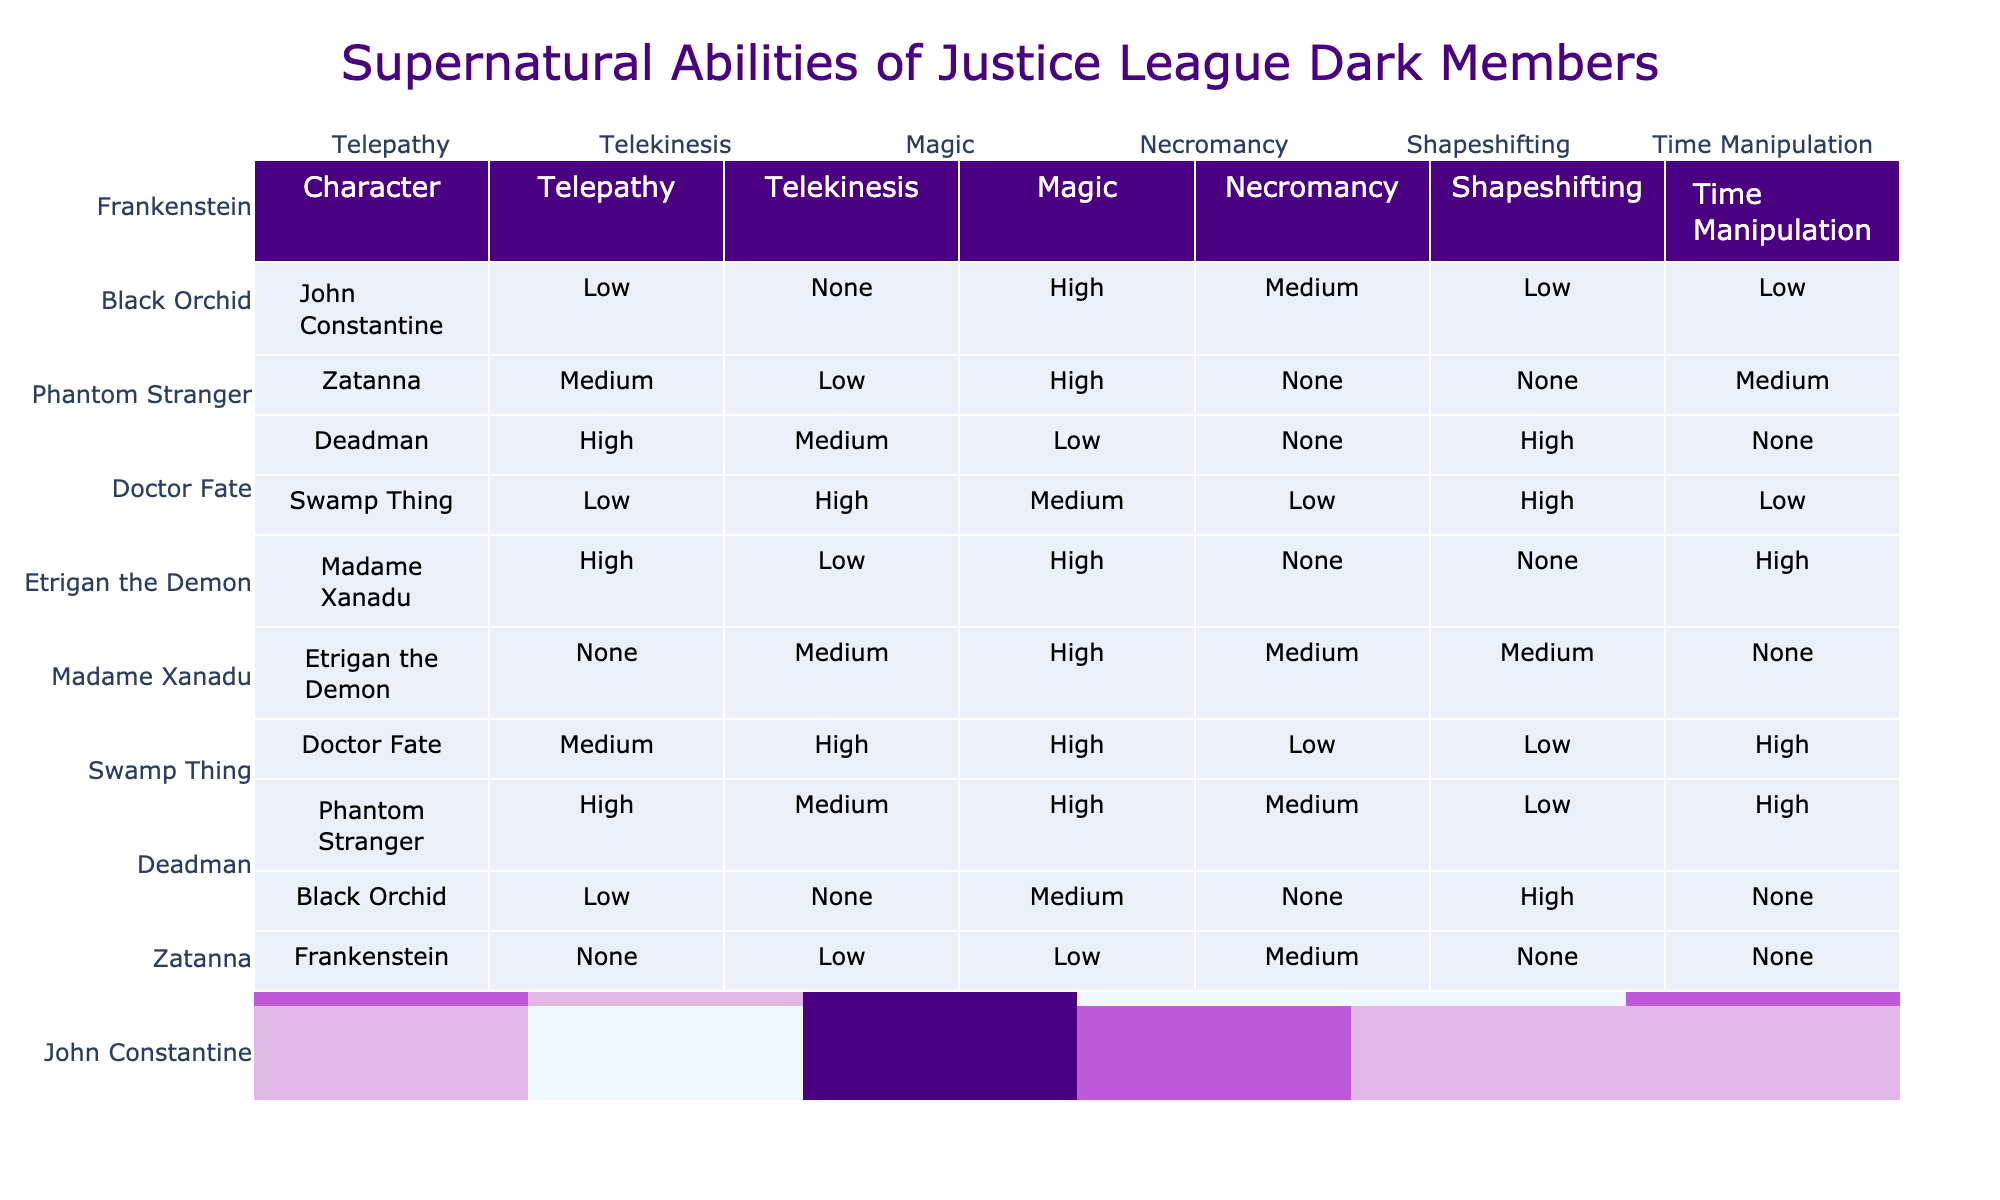What is the highest telepathy rating among the characters? By examining the table, I look for the character with the highest value under the telepathy column. Deadman has a "High" rating, which corresponds to a value of 3, and others have lower ratings.
Answer: Deadman Which character has the lowest rating in shapeshifting? The shapeshifting column is inspected for the character with the lowest value. Frankenstein has a "None" rating, which indicates the lowest possible value.
Answer: Frankenstein How many characters have a high rating in magic? I check the magic column and count the characters with a "High" rating. John Constantine, Zatanna, Etrigan the Demon, Madame Xanadu, Doctor Fate, and Phantom Stranger all have high ratings, totaling 6 characters.
Answer: 6 Which character shows the ability of time manipulation? Looking at the time manipulation column, I see that Deadman, Madame Xanadu, Doctor Fate, Phantom Stranger, and Swamp Thing have specified ratings, indicating they have this ability.
Answer: 5 characters Is there any character with no telekinesis ability? I check the telekinesis column for any "None" ratings. John Constantine, Zatanna, Black Orchid, and Frankenstein show "None," confirming that there are characters without this ability.
Answer: Yes What is the average rating of necromancy for Justice League Dark members? I first assign numerical values to the necromancy ratings: Low=1, Medium=2, High=3. The ratings are: Medium (2) for John Constantine, None (0) for Zatanna, None (0) for Deadman, Low (1) for Swamp Thing, Medium (2) for Etrigan, None (0) for Madame Xanadu, Low (1) for Phantom Stranger, None (0) for Black Orchid, Medium (1) for Frankenstein. The total sum is 2 + 0 + 0 + 1 + 2 + 0 + 1 + 0 + 1 = 7, and there are 9 members, which results in an average of 7/9 = 0.78, rounded to two decimal places gives 0.78.
Answer: 0.78 Which members possess at least two abilities rated as "High"? I check each character's abilities and identify those with two or more "High" ratings. Both Madame Xanadu and Etrigan have high ratings in magic and time manipulation, while Doctor Fate also shows high ratings in telekinesis and magic. There are 3 characters matching this criteria.
Answer: 3 characters 